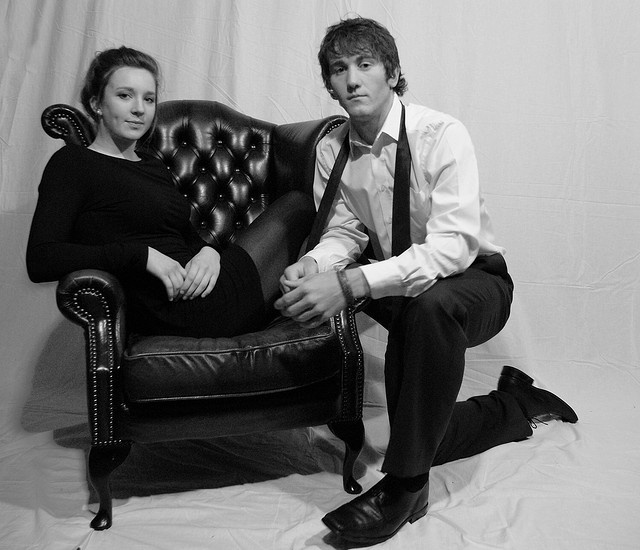Describe the objects in this image and their specific colors. I can see people in darkgray, black, gainsboro, and gray tones, chair in darkgray, black, gray, and lightgray tones, people in darkgray, black, gray, and lightgray tones, and tie in darkgray, black, gray, and lightgray tones in this image. 